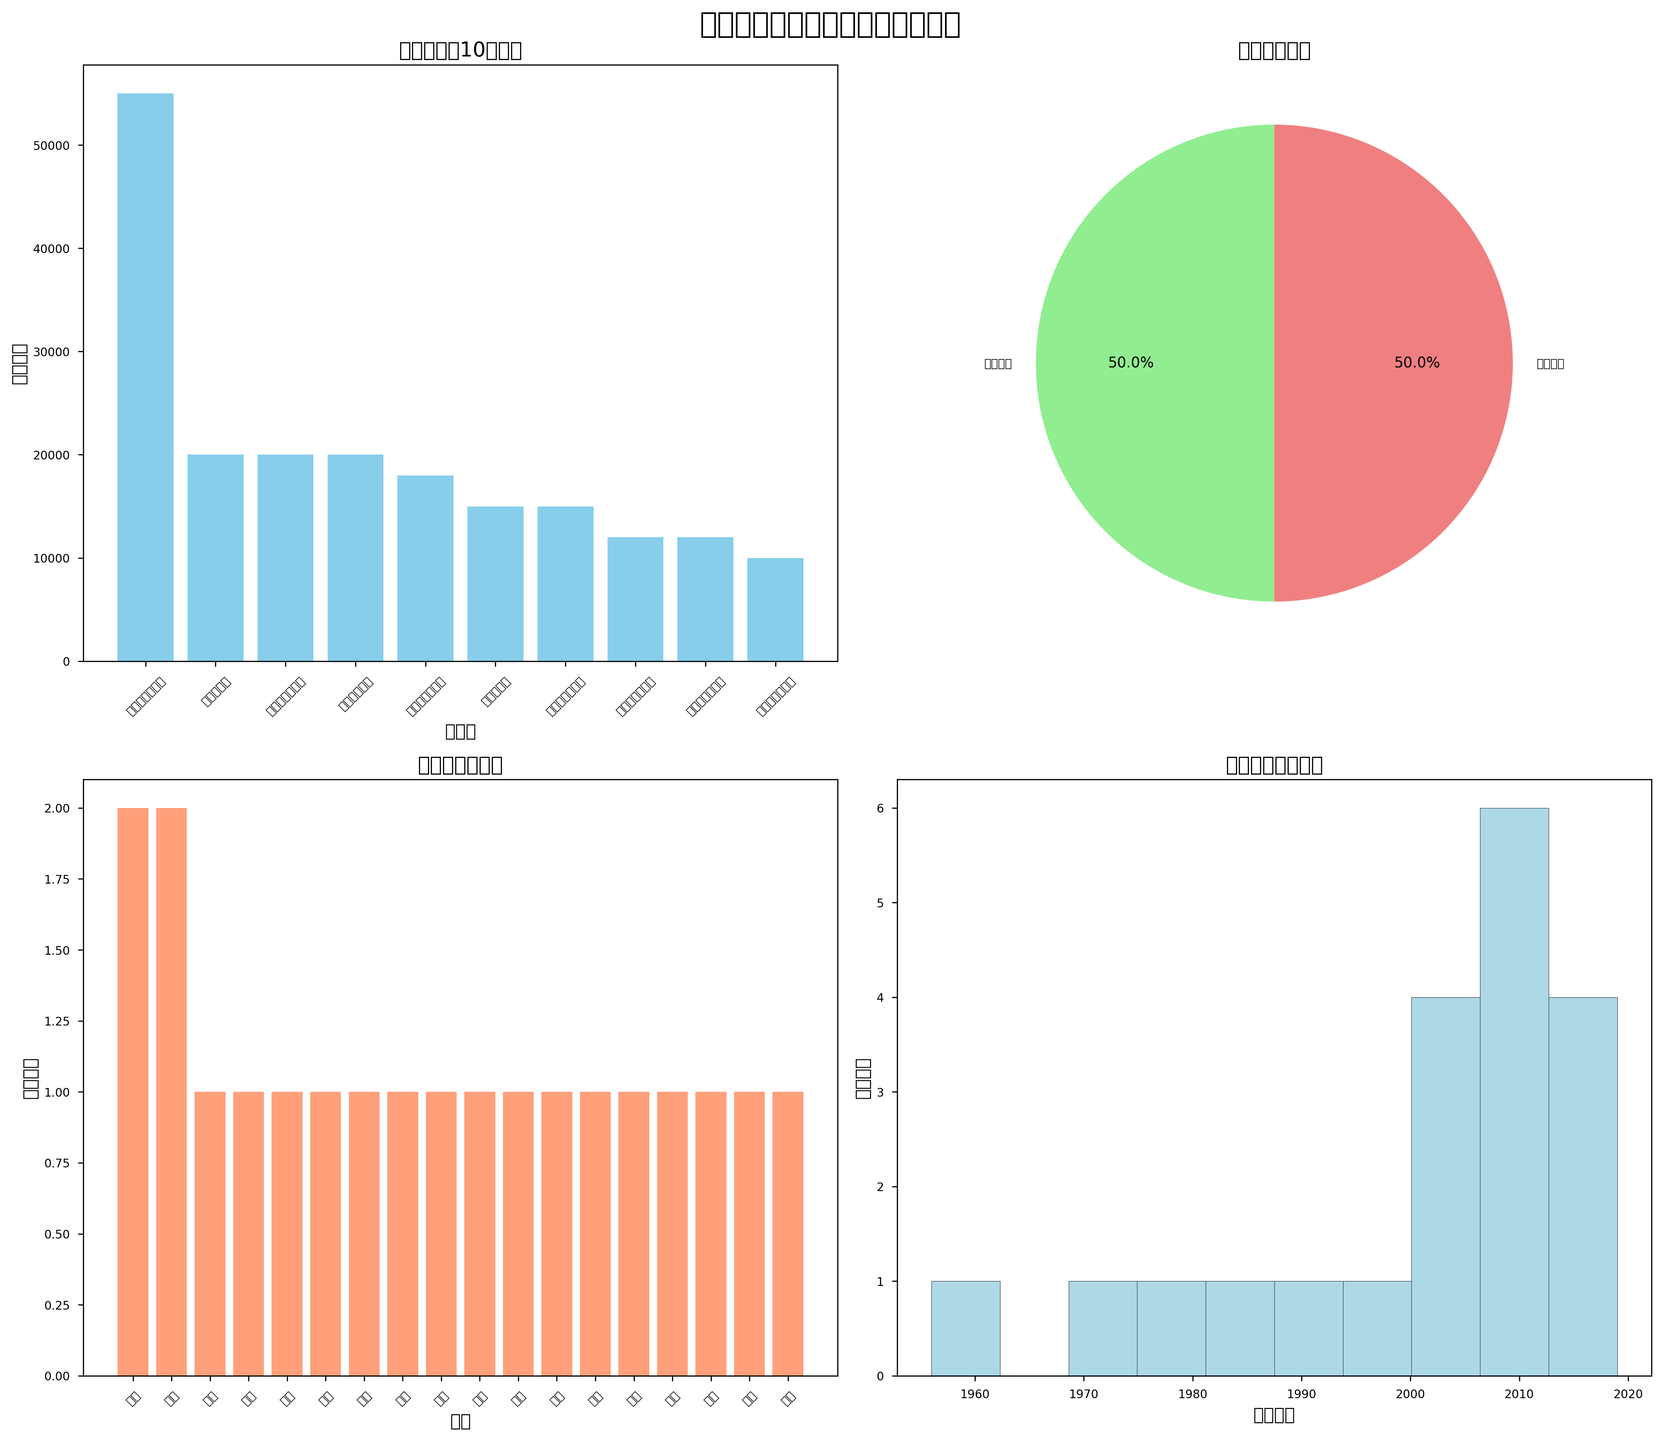足球場地的分布情況如何？ 從下方左圖的柱狀圖可以看到各城市有多少個足球場地，其中擁有最多場地的城市是高雄
Answer: 高雄 哪種類型的場地最多？ 下方右圖中的餅圖顯示場地類型的分布，其中標註顏色"lightgreen"的天然草皮占比最大
Answer: 天然草皮 哪個足球場的容納人數最多？ 從左上圖的柱狀圖中可以看到容納人數最多的足球場是高雄國家體育場
Answer: 高雄國家體育場 哪個年份建造的場地數量最多？ 下方右圖的直方圖顯示建造年份的分布，其中建造數量最多的年份集中在2000年代初期
Answer: 2000年代初期 台北有多少個球場？ 從下方左圖的柱狀圖中可以看到台北市只有一個球場
Answer: 1 哪些城市有2個或更多的足球場？ 從下方左圖的柱狀圖可以看到擁有2個或更多足球場地的城市包括台中和高雄
Answer: 台中和高雄 有多少場地容納人數大於10000人？ 從左上圖的柱狀圖可以看到，至少有10個場地容納人數大於10000人
Answer: 10 新竹的足球場容納人數是最少的嗎？ 下方左圖顯示新竹市立體育場的容納人數並不是最少的，因為有城市的踢球容納了5000人
Answer: 不是 將天然草皮場地容納人數加起來總共有多少？ 從數據表中可以看到天然草皮場地的容納人數分別為20000, 20000, 18000, 55000, 20000, 15000, 5000, 10000, 8000，將它們相加總共是181000
Answer: 181000 